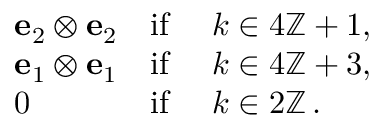<formula> <loc_0><loc_0><loc_500><loc_500>\begin{array} { r l r l } & { { e } _ { 2 } \otimes { e } _ { 2 } } & { i f } & { \ k \in 4 { \mathbb { Z } } + 1 , } \\ & { { e } _ { 1 } \otimes { e } _ { 1 } } & { i f } & { \ k \in 4 { \mathbb { Z } } + 3 , } \\ & { 0 } & { i f } & { \ k \in 2 { \mathbb { Z } } \, . } \end{array}</formula> 